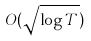<formula> <loc_0><loc_0><loc_500><loc_500>O ( \sqrt { \log T } )</formula> 